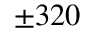Convert formula to latex. <formula><loc_0><loc_0><loc_500><loc_500>\pm 3 2 0</formula> 